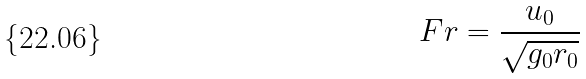Convert formula to latex. <formula><loc_0><loc_0><loc_500><loc_500>F r = \frac { u _ { 0 } } { \sqrt { g _ { 0 } r _ { 0 } } }</formula> 